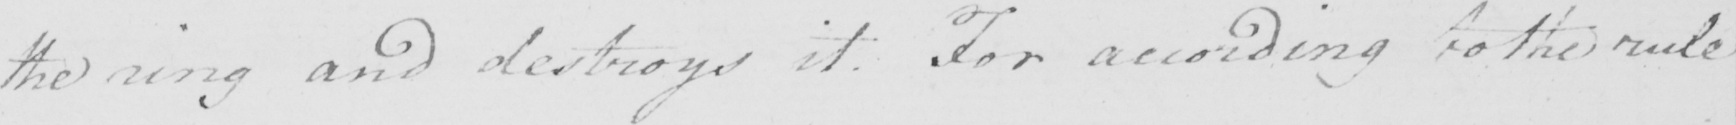Can you tell me what this handwritten text says? the ring and destroys it . For according to the rule 